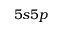Convert formula to latex. <formula><loc_0><loc_0><loc_500><loc_500>5 s 5 p</formula> 